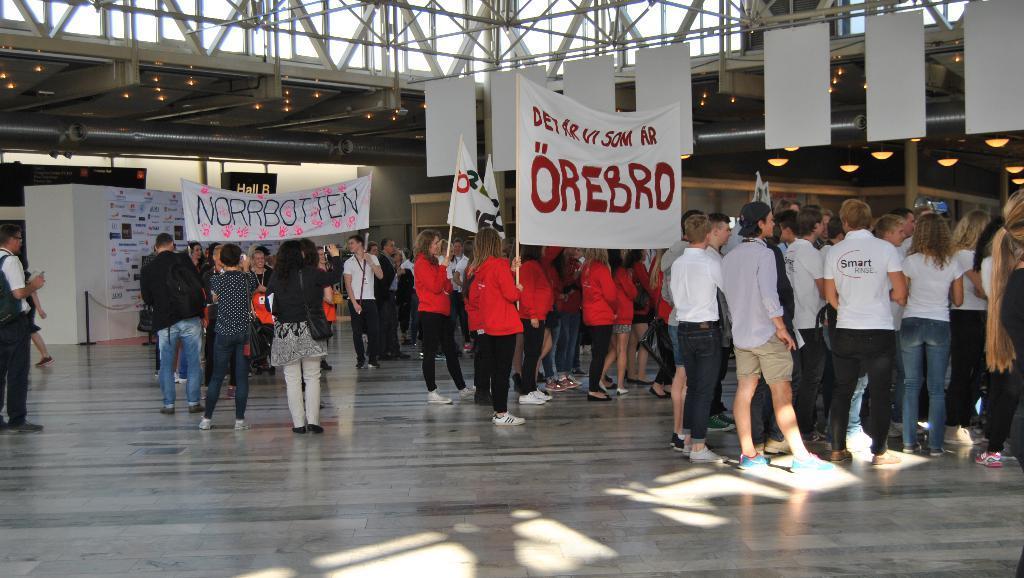In one or two sentences, can you explain what this image depicts? In the middle a group of people are standing with the banner, they wore red color coats, black color trousers. On the right side few men are standing, they wore white color t-shirts, on the left side few persons are standing they wore black color t-shirts, there are lights to the roof. 